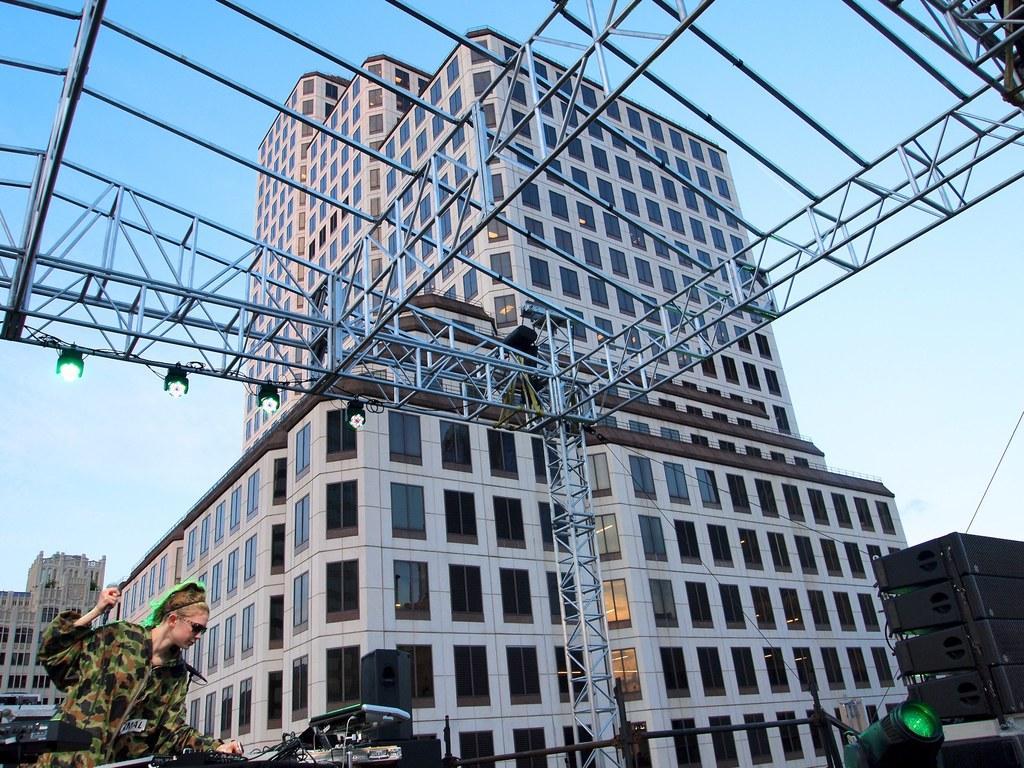Could you give a brief overview of what you see in this image? There is one woman standing at the bottom left corner of this image and there are some buildings in the background. There are some lights in the middle of this image and at the bottom of this image as well. There is a sky at the top of this image. 